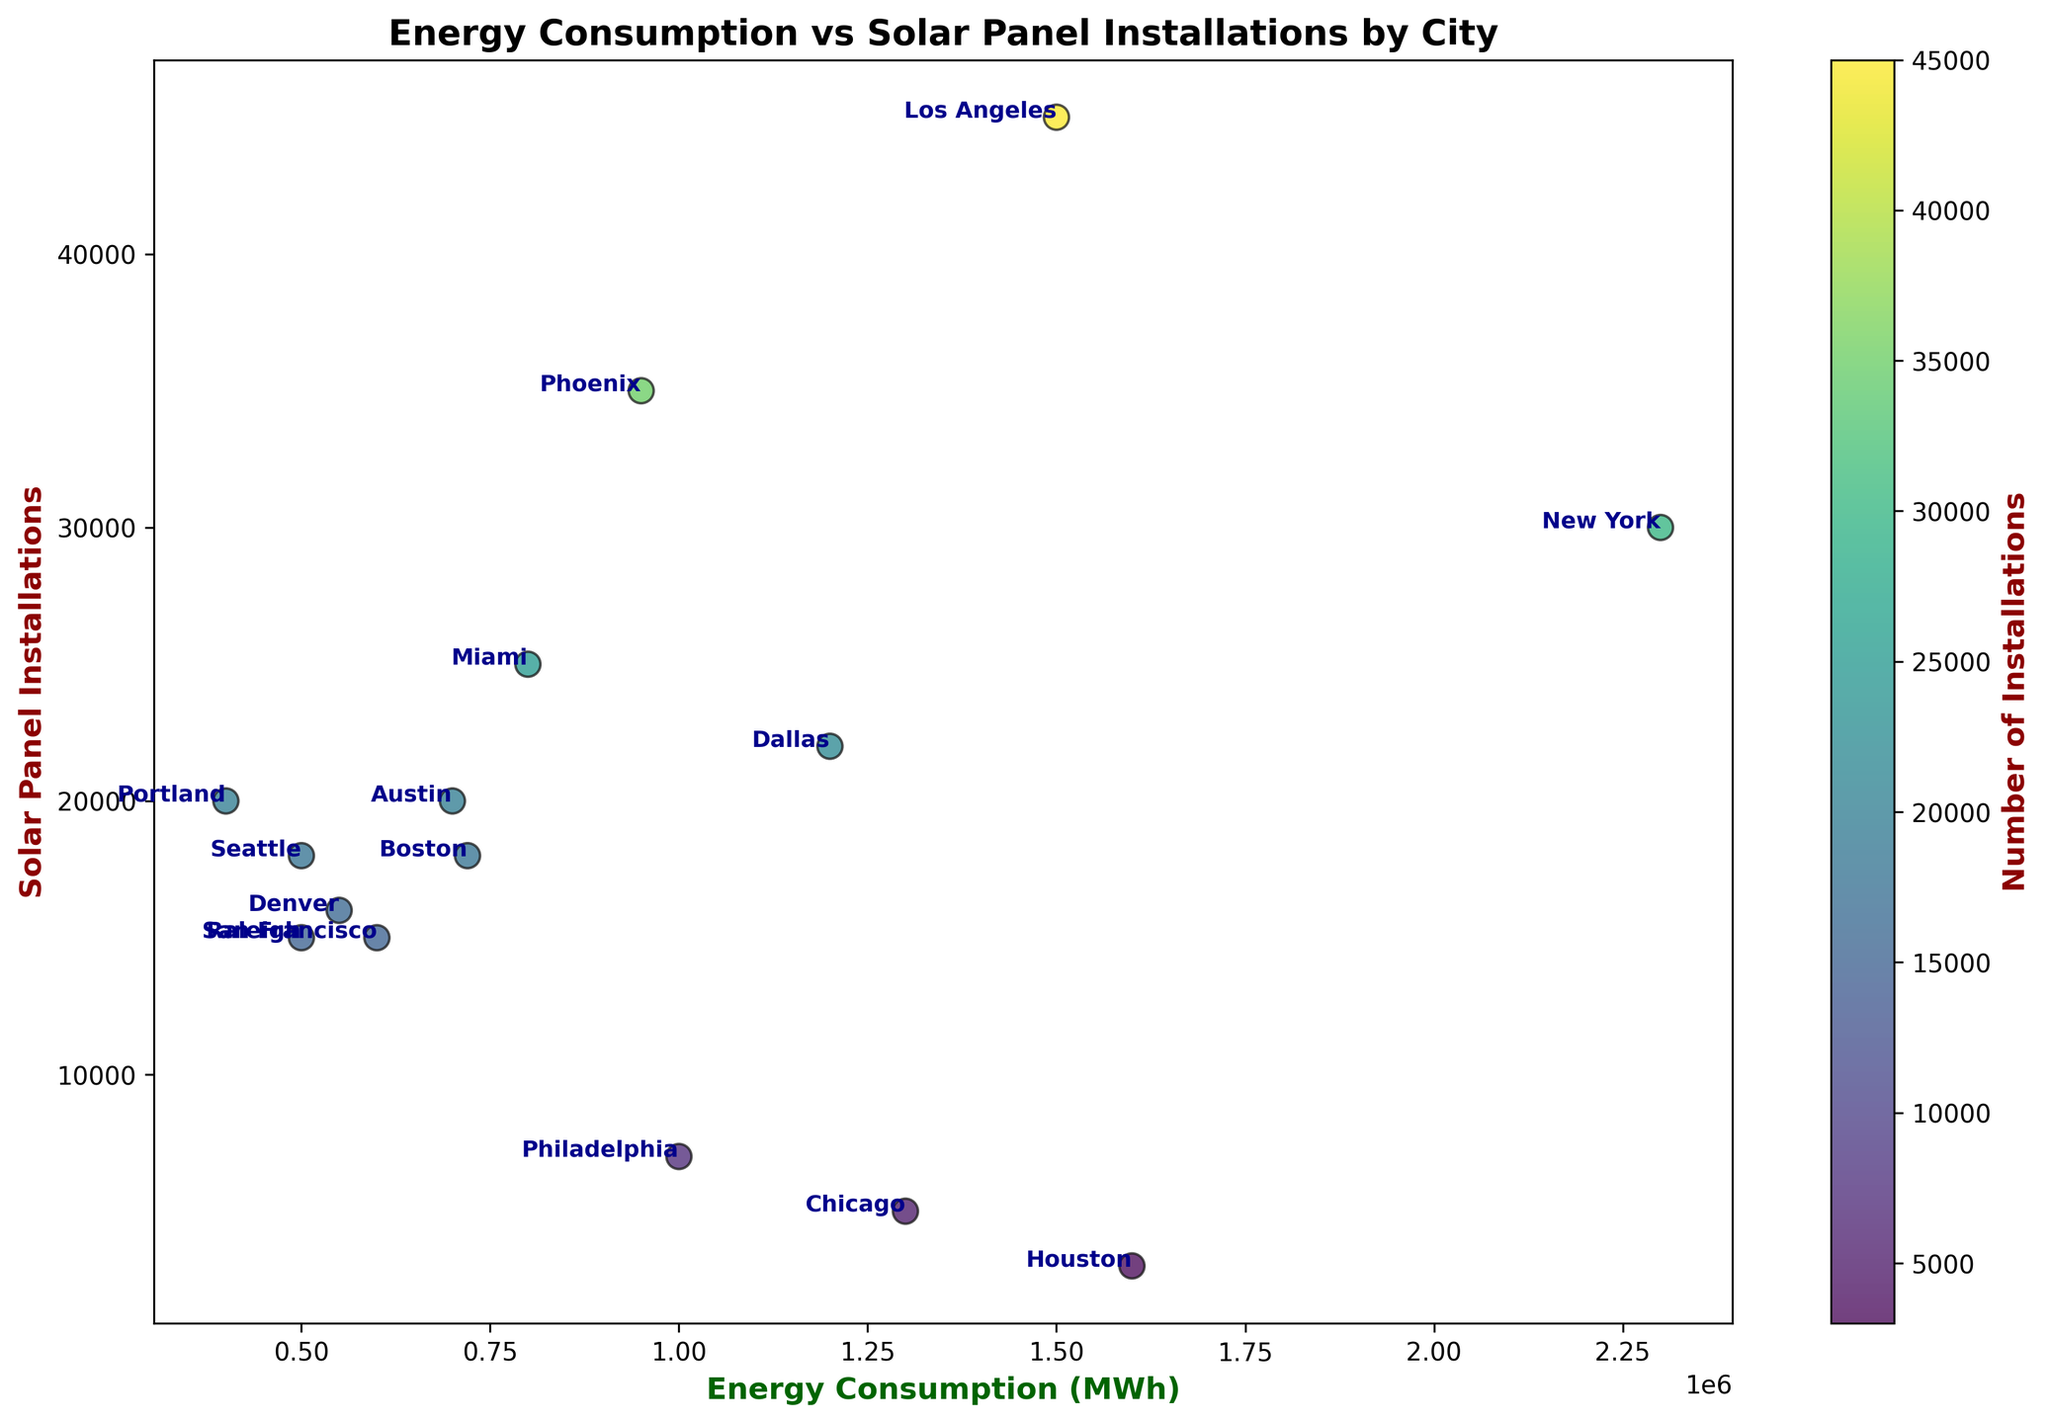Which city has the highest number of solar panel installations? The scatter plot indicates this by the position with the highest y-value. Here, Los Angeles has the highest value for solar panel installations.
Answer: Los Angeles Which city consumes the most energy? The city with the highest x-value represents the maximum energy consumption. This is New York, which has the largest x-coordinate in the plot.
Answer: New York How does Seattle compare to Dallas in terms of energy consumption and solar panel installations? In the scatter plot, Seattle lies to the left of Dallas in terms of energy consumption and has a similar y-value indicating solar panel installations. Hence, Seattle consumes less energy than Dallas but has a similar number of solar panel installations.
Answer: Seattle consumes less energy but has a similar number of installations Which city has the lowest ratio of solar panel installations to energy consumption? To find this, divide the number of solar panel installations by energy consumption for each city. The lowest ratio would be for a city in the lower-left part of the plot. Houston has very high energy consumption but very few solar panel installations, indicating the lowest ratio.
Answer: Houston What's the average number of solar panel installations across all cities? Sum the number of installations for all cities and divide by the number of cities. The total installations sum up to 286,000, and there are 15 cities, so the average is 286,000 / 15.
Answer: 19,067 If we categorize cities with energy consumption above 1,000,000 MWh as 'high consumption,' which of these cities have more than 20,000 solar panel installations? Filter the high consumption cities (New York, Los Angeles, Houston, Chicago, Dallas) and inspect the y-values. Los Angeles and Dallas have more than 20,000 installations.
Answer: Los Angeles, Dallas Which cities have more solar panel installations but consume less energy than Austin? Identify cities with a smaller x-value (less energy) but a higher y-value (more installations) than Austin (700,000 MWh, 20,000 installations). Portland and San Francisco meet these criteria.
Answer: San Francisco, Portland Which city has the closest number of solar panel installations to its energy consumption value divided by 40? Calculate energy consumption divided by 40 for each city and compare it to the number of solar panel installations. Denver has 550,000 MWh divided by 40, and approximately 13,750 installations, close to 16,000 installations it has.
Answer: Denver 